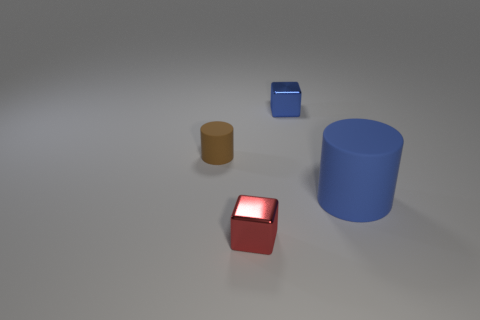There is a large matte thing; does it have the same color as the block behind the large blue thing?
Provide a short and direct response. Yes. How many other objects are there of the same color as the big matte thing?
Offer a very short reply. 1. Are there any other things that have the same size as the red thing?
Give a very brief answer. Yes. Are there more large matte objects than small purple metal cylinders?
Provide a succinct answer. Yes. How big is the object that is both on the right side of the red metallic thing and in front of the tiny cylinder?
Offer a terse response. Large. The brown object is what shape?
Your response must be concise. Cylinder. How many other cyan rubber things have the same shape as the small matte thing?
Keep it short and to the point. 0. Are there fewer tiny red metallic cubes behind the small red block than things in front of the blue metal object?
Your response must be concise. Yes. There is a red cube that is to the left of the small blue thing; how many small metal blocks are behind it?
Offer a very short reply. 1. Is there a gray rubber block?
Make the answer very short. No. 